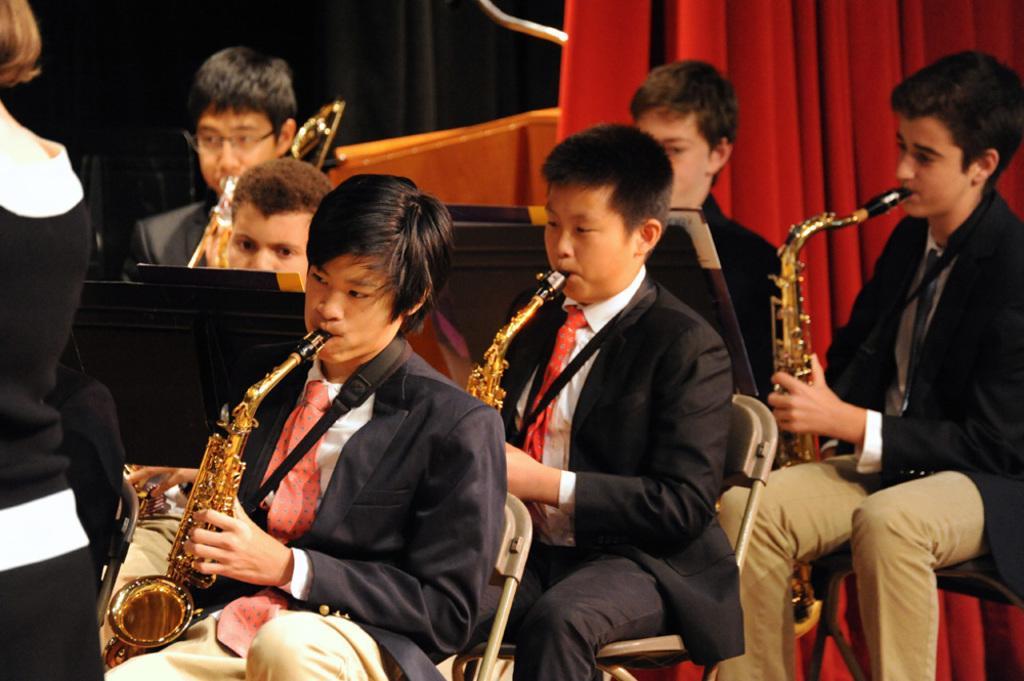Can you describe this image briefly? In this image I can see the group of people sitting and holding the trumpets. In-front of these people I can see the one person standing. In the background I can see the red and black color curtain. 